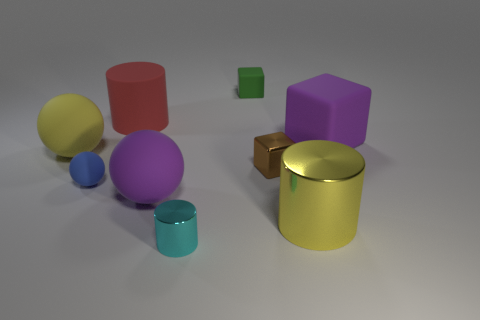There is a rubber sphere that is the same color as the large rubber block; what is its size?
Your response must be concise. Large. There is a cylinder that is the same size as the green object; what is its color?
Keep it short and to the point. Cyan. Is the number of metal cylinders on the left side of the red rubber object less than the number of large yellow metallic things that are in front of the big yellow ball?
Make the answer very short. Yes. There is a purple thing that is on the right side of the big purple thing in front of the brown shiny thing; how many small metal things are to the right of it?
Make the answer very short. 0. What size is the cyan object that is the same shape as the red thing?
Your answer should be compact. Small. Is the number of yellow matte things that are in front of the green object less than the number of purple metallic objects?
Offer a terse response. No. Is the shape of the tiny blue object the same as the yellow rubber object?
Provide a short and direct response. Yes. There is a big shiny thing that is the same shape as the red rubber object; what is its color?
Offer a very short reply. Yellow. How many rubber spheres have the same color as the big metallic object?
Keep it short and to the point. 1. What number of objects are spheres to the right of the big yellow sphere or small brown things?
Offer a very short reply. 3. 